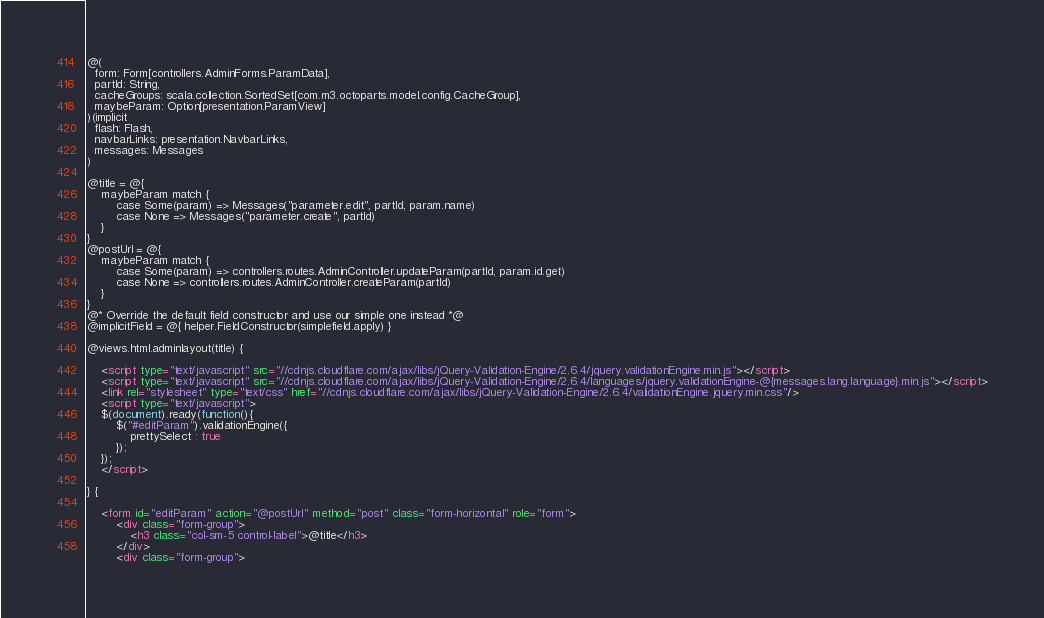<code> <loc_0><loc_0><loc_500><loc_500><_HTML_>@(
  form: Form[controllers.AdminForms.ParamData],
  partId: String,
  cacheGroups: scala.collection.SortedSet[com.m3.octoparts.model.config.CacheGroup],
  maybeParam: Option[presentation.ParamView]
)(implicit
  flash: Flash,
  navbarLinks: presentation.NavbarLinks,
  messages: Messages
)

@title = @{
    maybeParam match {
        case Some(param) => Messages("parameter.edit", partId, param.name)
        case None => Messages("parameter.create", partId)
    }
}
@postUrl = @{
    maybeParam match {
        case Some(param) => controllers.routes.AdminController.updateParam(partId, param.id.get)
        case None => controllers.routes.AdminController.createParam(partId)
    }
}
@* Override the default field constructor and use our simple one instead *@
@implicitField = @{ helper.FieldConstructor(simplefield.apply) }

@views.html.adminlayout(title) {

    <script type="text/javascript" src="//cdnjs.cloudflare.com/ajax/libs/jQuery-Validation-Engine/2.6.4/jquery.validationEngine.min.js"></script>
    <script type="text/javascript" src="//cdnjs.cloudflare.com/ajax/libs/jQuery-Validation-Engine/2.6.4/languages/jquery.validationEngine-@{messages.lang.language}.min.js"></script>
    <link rel="stylesheet" type="text/css" href="//cdnjs.cloudflare.com/ajax/libs/jQuery-Validation-Engine/2.6.4/validationEngine.jquery.min.css"/>
    <script type="text/javascript">
    $(document).ready(function(){
        $("#editParam").validationEngine({
            prettySelect : true
        });
    });
    </script>

} {

    <form id="editParam" action="@postUrl" method="post" class="form-horizontal" role="form">
        <div class="form-group">
            <h3 class="col-sm-5 control-label">@title</h3>
        </div>
        <div class="form-group"></code> 